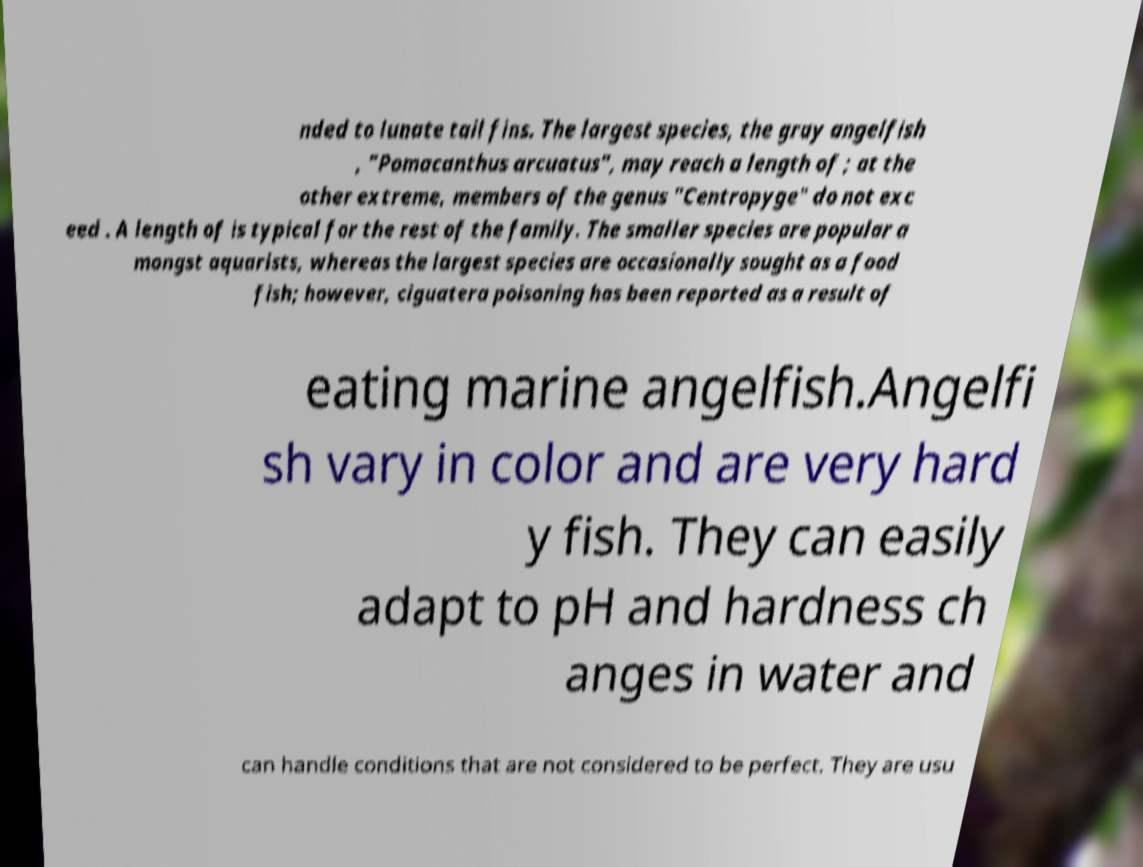For documentation purposes, I need the text within this image transcribed. Could you provide that? nded to lunate tail fins. The largest species, the gray angelfish , "Pomacanthus arcuatus", may reach a length of ; at the other extreme, members of the genus "Centropyge" do not exc eed . A length of is typical for the rest of the family. The smaller species are popular a mongst aquarists, whereas the largest species are occasionally sought as a food fish; however, ciguatera poisoning has been reported as a result of eating marine angelfish.Angelfi sh vary in color and are very hard y fish. They can easily adapt to pH and hardness ch anges in water and can handle conditions that are not considered to be perfect. They are usu 